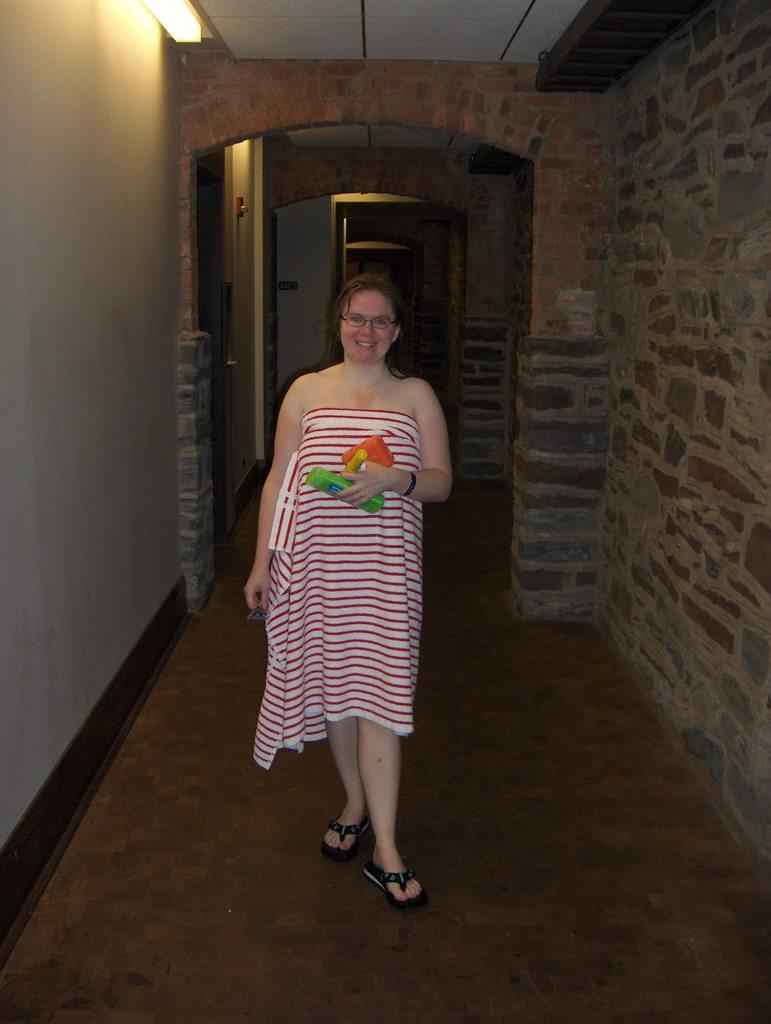What is the main subject of the image? There is a person standing in the image. What is the person doing in the image? The person is holding objects. What can be seen in the background of the image? There is a brick wall in the background of the image. What is the source of light in the image? There is a light visible at the top of the image. Can you see any feathers floating in the stream in the image? There is no stream or feathers present in the image. 